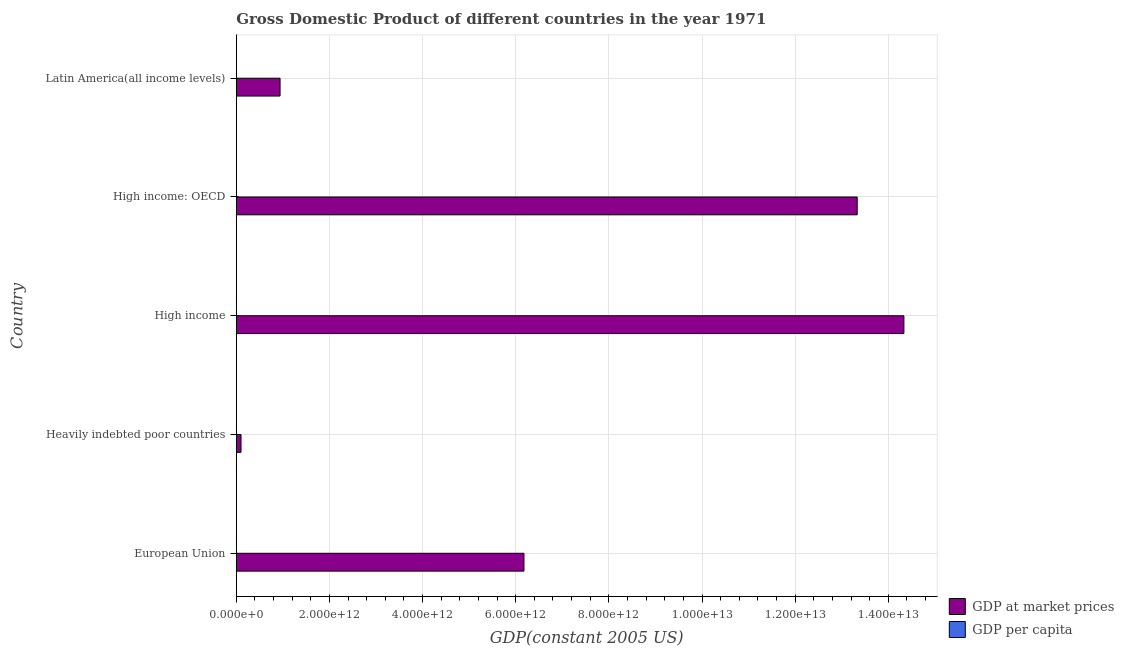How many different coloured bars are there?
Make the answer very short. 2. How many groups of bars are there?
Ensure brevity in your answer.  5. Are the number of bars per tick equal to the number of legend labels?
Ensure brevity in your answer.  Yes. How many bars are there on the 4th tick from the bottom?
Offer a very short reply. 2. What is the label of the 2nd group of bars from the top?
Ensure brevity in your answer.  High income: OECD. What is the gdp per capita in High income: OECD?
Keep it short and to the point. 1.64e+04. Across all countries, what is the maximum gdp at market prices?
Your response must be concise. 1.43e+13. Across all countries, what is the minimum gdp at market prices?
Provide a short and direct response. 1.02e+11. In which country was the gdp at market prices minimum?
Keep it short and to the point. Heavily indebted poor countries. What is the total gdp at market prices in the graph?
Provide a succinct answer. 3.49e+13. What is the difference between the gdp per capita in Heavily indebted poor countries and that in Latin America(all income levels)?
Provide a succinct answer. -2709.73. What is the difference between the gdp at market prices in High income: OECD and the gdp per capita in European Union?
Your answer should be very brief. 1.33e+13. What is the average gdp at market prices per country?
Your answer should be very brief. 6.98e+12. What is the difference between the gdp at market prices and gdp per capita in High income?
Ensure brevity in your answer.  1.43e+13. In how many countries, is the gdp at market prices greater than 14000000000000 US$?
Keep it short and to the point. 1. What is the ratio of the gdp at market prices in European Union to that in Heavily indebted poor countries?
Keep it short and to the point. 60.36. Is the difference between the gdp per capita in High income: OECD and Latin America(all income levels) greater than the difference between the gdp at market prices in High income: OECD and Latin America(all income levels)?
Ensure brevity in your answer.  No. What is the difference between the highest and the second highest gdp per capita?
Ensure brevity in your answer.  2485.5. What is the difference between the highest and the lowest gdp at market prices?
Provide a short and direct response. 1.42e+13. In how many countries, is the gdp at market prices greater than the average gdp at market prices taken over all countries?
Make the answer very short. 2. Is the sum of the gdp per capita in Heavily indebted poor countries and High income greater than the maximum gdp at market prices across all countries?
Keep it short and to the point. No. What does the 1st bar from the top in Heavily indebted poor countries represents?
Offer a terse response. GDP per capita. What does the 2nd bar from the bottom in Latin America(all income levels) represents?
Keep it short and to the point. GDP per capita. How many bars are there?
Offer a terse response. 10. Are all the bars in the graph horizontal?
Ensure brevity in your answer.  Yes. How many countries are there in the graph?
Keep it short and to the point. 5. What is the difference between two consecutive major ticks on the X-axis?
Your answer should be compact. 2.00e+12. Does the graph contain grids?
Your response must be concise. Yes. How many legend labels are there?
Your answer should be compact. 2. How are the legend labels stacked?
Your answer should be compact. Vertical. What is the title of the graph?
Make the answer very short. Gross Domestic Product of different countries in the year 1971. What is the label or title of the X-axis?
Provide a succinct answer. GDP(constant 2005 US). What is the GDP(constant 2005 US) of GDP at market prices in European Union?
Ensure brevity in your answer.  6.18e+12. What is the GDP(constant 2005 US) of GDP per capita in European Union?
Your response must be concise. 1.39e+04. What is the GDP(constant 2005 US) in GDP at market prices in Heavily indebted poor countries?
Offer a very short reply. 1.02e+11. What is the GDP(constant 2005 US) in GDP per capita in Heavily indebted poor countries?
Provide a succinct answer. 478.26. What is the GDP(constant 2005 US) in GDP at market prices in High income?
Make the answer very short. 1.43e+13. What is the GDP(constant 2005 US) of GDP per capita in High income?
Provide a succinct answer. 1.39e+04. What is the GDP(constant 2005 US) of GDP at market prices in High income: OECD?
Make the answer very short. 1.33e+13. What is the GDP(constant 2005 US) of GDP per capita in High income: OECD?
Keep it short and to the point. 1.64e+04. What is the GDP(constant 2005 US) in GDP at market prices in Latin America(all income levels)?
Your response must be concise. 9.41e+11. What is the GDP(constant 2005 US) of GDP per capita in Latin America(all income levels)?
Provide a short and direct response. 3188. Across all countries, what is the maximum GDP(constant 2005 US) in GDP at market prices?
Give a very brief answer. 1.43e+13. Across all countries, what is the maximum GDP(constant 2005 US) in GDP per capita?
Your response must be concise. 1.64e+04. Across all countries, what is the minimum GDP(constant 2005 US) in GDP at market prices?
Your answer should be very brief. 1.02e+11. Across all countries, what is the minimum GDP(constant 2005 US) of GDP per capita?
Offer a very short reply. 478.26. What is the total GDP(constant 2005 US) in GDP at market prices in the graph?
Your answer should be very brief. 3.49e+13. What is the total GDP(constant 2005 US) in GDP per capita in the graph?
Keep it short and to the point. 4.79e+04. What is the difference between the GDP(constant 2005 US) of GDP at market prices in European Union and that in Heavily indebted poor countries?
Provide a short and direct response. 6.07e+12. What is the difference between the GDP(constant 2005 US) of GDP per capita in European Union and that in Heavily indebted poor countries?
Keep it short and to the point. 1.34e+04. What is the difference between the GDP(constant 2005 US) of GDP at market prices in European Union and that in High income?
Provide a short and direct response. -8.16e+12. What is the difference between the GDP(constant 2005 US) in GDP per capita in European Union and that in High income?
Keep it short and to the point. -46.49. What is the difference between the GDP(constant 2005 US) of GDP at market prices in European Union and that in High income: OECD?
Give a very brief answer. -7.15e+12. What is the difference between the GDP(constant 2005 US) in GDP per capita in European Union and that in High income: OECD?
Give a very brief answer. -2531.99. What is the difference between the GDP(constant 2005 US) of GDP at market prices in European Union and that in Latin America(all income levels)?
Offer a terse response. 5.24e+12. What is the difference between the GDP(constant 2005 US) of GDP per capita in European Union and that in Latin America(all income levels)?
Make the answer very short. 1.07e+04. What is the difference between the GDP(constant 2005 US) of GDP at market prices in Heavily indebted poor countries and that in High income?
Make the answer very short. -1.42e+13. What is the difference between the GDP(constant 2005 US) of GDP per capita in Heavily indebted poor countries and that in High income?
Make the answer very short. -1.35e+04. What is the difference between the GDP(constant 2005 US) in GDP at market prices in Heavily indebted poor countries and that in High income: OECD?
Provide a succinct answer. -1.32e+13. What is the difference between the GDP(constant 2005 US) in GDP per capita in Heavily indebted poor countries and that in High income: OECD?
Your answer should be compact. -1.60e+04. What is the difference between the GDP(constant 2005 US) of GDP at market prices in Heavily indebted poor countries and that in Latin America(all income levels)?
Your response must be concise. -8.38e+11. What is the difference between the GDP(constant 2005 US) of GDP per capita in Heavily indebted poor countries and that in Latin America(all income levels)?
Give a very brief answer. -2709.73. What is the difference between the GDP(constant 2005 US) of GDP at market prices in High income and that in High income: OECD?
Offer a terse response. 1.00e+12. What is the difference between the GDP(constant 2005 US) of GDP per capita in High income and that in High income: OECD?
Provide a succinct answer. -2485.5. What is the difference between the GDP(constant 2005 US) of GDP at market prices in High income and that in Latin America(all income levels)?
Provide a short and direct response. 1.34e+13. What is the difference between the GDP(constant 2005 US) of GDP per capita in High income and that in Latin America(all income levels)?
Provide a succinct answer. 1.08e+04. What is the difference between the GDP(constant 2005 US) in GDP at market prices in High income: OECD and that in Latin America(all income levels)?
Give a very brief answer. 1.24e+13. What is the difference between the GDP(constant 2005 US) in GDP per capita in High income: OECD and that in Latin America(all income levels)?
Offer a very short reply. 1.32e+04. What is the difference between the GDP(constant 2005 US) in GDP at market prices in European Union and the GDP(constant 2005 US) in GDP per capita in Heavily indebted poor countries?
Keep it short and to the point. 6.18e+12. What is the difference between the GDP(constant 2005 US) of GDP at market prices in European Union and the GDP(constant 2005 US) of GDP per capita in High income?
Give a very brief answer. 6.18e+12. What is the difference between the GDP(constant 2005 US) in GDP at market prices in European Union and the GDP(constant 2005 US) in GDP per capita in High income: OECD?
Your answer should be compact. 6.18e+12. What is the difference between the GDP(constant 2005 US) in GDP at market prices in European Union and the GDP(constant 2005 US) in GDP per capita in Latin America(all income levels)?
Your answer should be compact. 6.18e+12. What is the difference between the GDP(constant 2005 US) in GDP at market prices in Heavily indebted poor countries and the GDP(constant 2005 US) in GDP per capita in High income?
Keep it short and to the point. 1.02e+11. What is the difference between the GDP(constant 2005 US) of GDP at market prices in Heavily indebted poor countries and the GDP(constant 2005 US) of GDP per capita in High income: OECD?
Make the answer very short. 1.02e+11. What is the difference between the GDP(constant 2005 US) in GDP at market prices in Heavily indebted poor countries and the GDP(constant 2005 US) in GDP per capita in Latin America(all income levels)?
Provide a succinct answer. 1.02e+11. What is the difference between the GDP(constant 2005 US) of GDP at market prices in High income and the GDP(constant 2005 US) of GDP per capita in High income: OECD?
Give a very brief answer. 1.43e+13. What is the difference between the GDP(constant 2005 US) in GDP at market prices in High income and the GDP(constant 2005 US) in GDP per capita in Latin America(all income levels)?
Give a very brief answer. 1.43e+13. What is the difference between the GDP(constant 2005 US) of GDP at market prices in High income: OECD and the GDP(constant 2005 US) of GDP per capita in Latin America(all income levels)?
Provide a short and direct response. 1.33e+13. What is the average GDP(constant 2005 US) in GDP at market prices per country?
Your answer should be very brief. 6.98e+12. What is the average GDP(constant 2005 US) of GDP per capita per country?
Give a very brief answer. 9589.25. What is the difference between the GDP(constant 2005 US) of GDP at market prices and GDP(constant 2005 US) of GDP per capita in European Union?
Offer a terse response. 6.18e+12. What is the difference between the GDP(constant 2005 US) of GDP at market prices and GDP(constant 2005 US) of GDP per capita in Heavily indebted poor countries?
Your answer should be compact. 1.02e+11. What is the difference between the GDP(constant 2005 US) of GDP at market prices and GDP(constant 2005 US) of GDP per capita in High income?
Make the answer very short. 1.43e+13. What is the difference between the GDP(constant 2005 US) of GDP at market prices and GDP(constant 2005 US) of GDP per capita in High income: OECD?
Give a very brief answer. 1.33e+13. What is the difference between the GDP(constant 2005 US) of GDP at market prices and GDP(constant 2005 US) of GDP per capita in Latin America(all income levels)?
Provide a succinct answer. 9.41e+11. What is the ratio of the GDP(constant 2005 US) in GDP at market prices in European Union to that in Heavily indebted poor countries?
Give a very brief answer. 60.36. What is the ratio of the GDP(constant 2005 US) in GDP per capita in European Union to that in Heavily indebted poor countries?
Keep it short and to the point. 29.06. What is the ratio of the GDP(constant 2005 US) in GDP at market prices in European Union to that in High income?
Your response must be concise. 0.43. What is the ratio of the GDP(constant 2005 US) of GDP per capita in European Union to that in High income?
Provide a short and direct response. 1. What is the ratio of the GDP(constant 2005 US) in GDP at market prices in European Union to that in High income: OECD?
Provide a succinct answer. 0.46. What is the ratio of the GDP(constant 2005 US) of GDP per capita in European Union to that in High income: OECD?
Offer a very short reply. 0.85. What is the ratio of the GDP(constant 2005 US) of GDP at market prices in European Union to that in Latin America(all income levels)?
Offer a very short reply. 6.57. What is the ratio of the GDP(constant 2005 US) in GDP per capita in European Union to that in Latin America(all income levels)?
Offer a very short reply. 4.36. What is the ratio of the GDP(constant 2005 US) in GDP at market prices in Heavily indebted poor countries to that in High income?
Provide a succinct answer. 0.01. What is the ratio of the GDP(constant 2005 US) of GDP per capita in Heavily indebted poor countries to that in High income?
Provide a succinct answer. 0.03. What is the ratio of the GDP(constant 2005 US) in GDP at market prices in Heavily indebted poor countries to that in High income: OECD?
Your response must be concise. 0.01. What is the ratio of the GDP(constant 2005 US) of GDP per capita in Heavily indebted poor countries to that in High income: OECD?
Make the answer very short. 0.03. What is the ratio of the GDP(constant 2005 US) in GDP at market prices in Heavily indebted poor countries to that in Latin America(all income levels)?
Make the answer very short. 0.11. What is the ratio of the GDP(constant 2005 US) of GDP at market prices in High income to that in High income: OECD?
Give a very brief answer. 1.08. What is the ratio of the GDP(constant 2005 US) of GDP per capita in High income to that in High income: OECD?
Your answer should be compact. 0.85. What is the ratio of the GDP(constant 2005 US) of GDP at market prices in High income to that in Latin America(all income levels)?
Ensure brevity in your answer.  15.24. What is the ratio of the GDP(constant 2005 US) of GDP per capita in High income to that in Latin America(all income levels)?
Offer a very short reply. 4.37. What is the ratio of the GDP(constant 2005 US) of GDP at market prices in High income: OECD to that in Latin America(all income levels)?
Provide a short and direct response. 14.17. What is the ratio of the GDP(constant 2005 US) of GDP per capita in High income: OECD to that in Latin America(all income levels)?
Give a very brief answer. 5.15. What is the difference between the highest and the second highest GDP(constant 2005 US) in GDP at market prices?
Offer a terse response. 1.00e+12. What is the difference between the highest and the second highest GDP(constant 2005 US) of GDP per capita?
Make the answer very short. 2485.5. What is the difference between the highest and the lowest GDP(constant 2005 US) in GDP at market prices?
Your response must be concise. 1.42e+13. What is the difference between the highest and the lowest GDP(constant 2005 US) in GDP per capita?
Ensure brevity in your answer.  1.60e+04. 